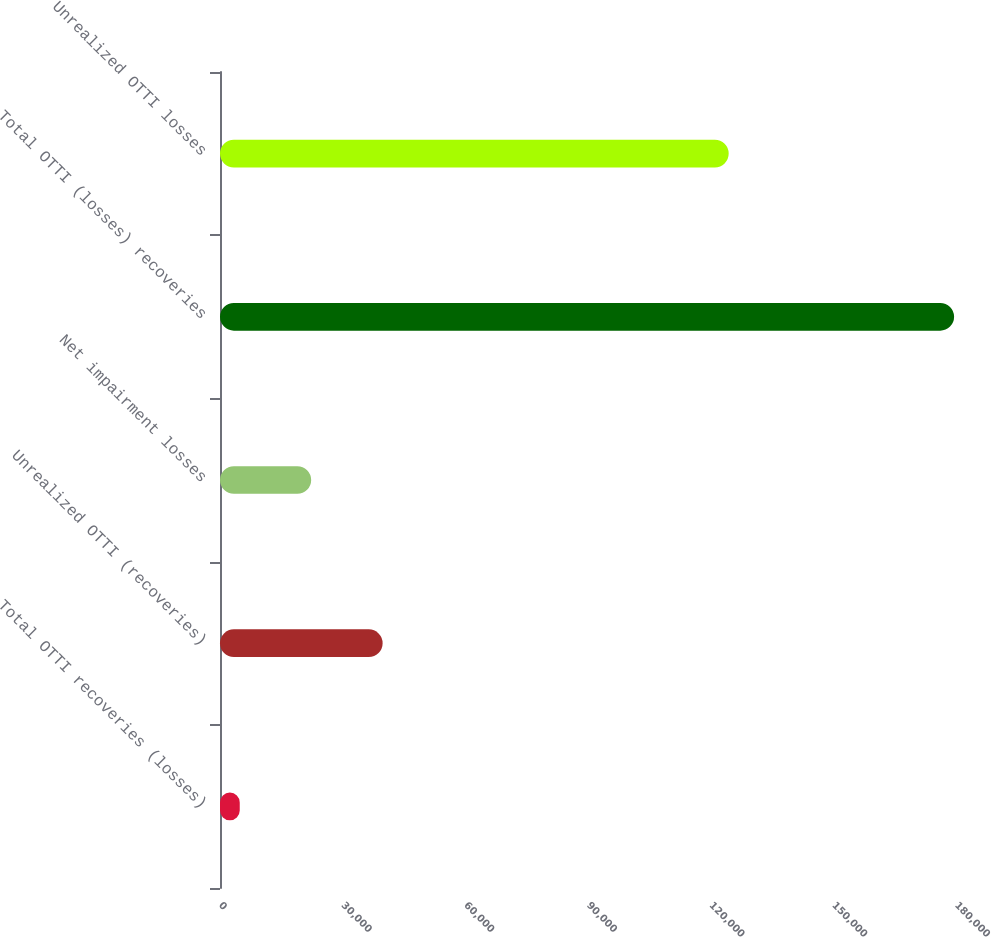Convert chart. <chart><loc_0><loc_0><loc_500><loc_500><bar_chart><fcel>Total OTTI recoveries (losses)<fcel>Unrealized OTTI (recoveries)<fcel>Net impairment losses<fcel>Total OTTI (losses) recoveries<fcel>Unrealized OTTI losses<nl><fcel>4828<fcel>39769.4<fcel>22298.7<fcel>179535<fcel>124408<nl></chart> 